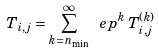<formula> <loc_0><loc_0><loc_500><loc_500>T _ { i , j } = \sum _ { k = n _ { \min } } ^ { \infty } \ e p ^ { k } \, T _ { i , j } ^ { ( k ) }</formula> 